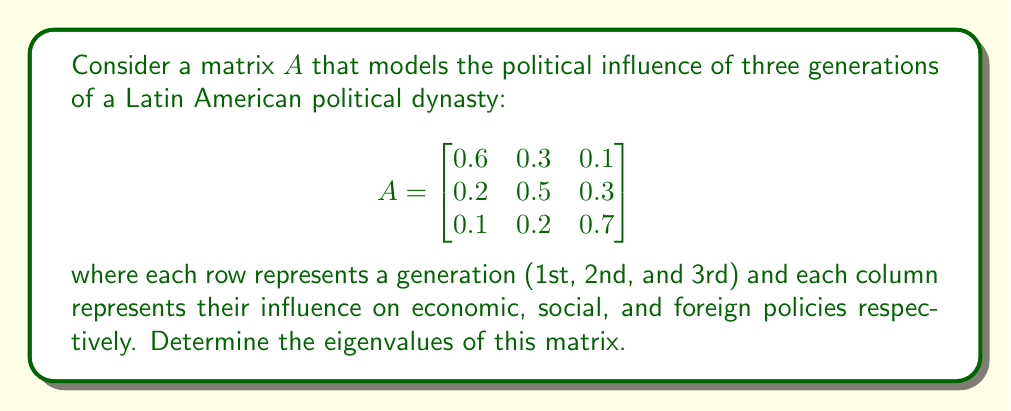Help me with this question. To find the eigenvalues of matrix $A$, we need to solve the characteristic equation:

$\det(A - \lambda I) = 0$

where $\lambda$ represents the eigenvalues and $I$ is the $3 \times 3$ identity matrix.

Step 1: Set up the characteristic equation
$$\det\begin{bmatrix}
0.6 - \lambda & 0.3 & 0.1 \\
0.2 & 0.5 - \lambda & 0.3 \\
0.1 & 0.2 & 0.7 - \lambda
\end{bmatrix} = 0$$

Step 2: Expand the determinant
$$(0.6 - \lambda)[(0.5 - \lambda)(0.7 - \lambda) - 0.06] - 0.3[0.2(0.7 - \lambda) - 0.03] + 0.1[0.2(0.5 - \lambda) - 0.06] = 0$$

Step 3: Simplify
$$(0.6 - \lambda)(0.35 - 1.2\lambda + \lambda^2) - 0.3(0.14 - 0.2\lambda) + 0.1(0.1 - 0.2\lambda) = 0$$

$0.21 - 0.72\lambda + 0.6\lambda^2 - 0.35\lambda + 1.2\lambda^2 - \lambda^3 - 0.042 + 0.06\lambda + 0.01 - 0.02\lambda = 0$

Step 4: Collect like terms
$-\lambda^3 + 1.8\lambda^2 - 1.03\lambda + 0.178 = 0$

Step 5: Solve the cubic equation
This cubic equation can be solved using numerical methods or a computer algebra system. The roots of this equation are the eigenvalues of matrix $A$.
Answer: The eigenvalues of matrix $A$ are approximately:

$\lambda_1 \approx 1$
$\lambda_2 \approx 0.5$
$\lambda_3 \approx 0.3$ 